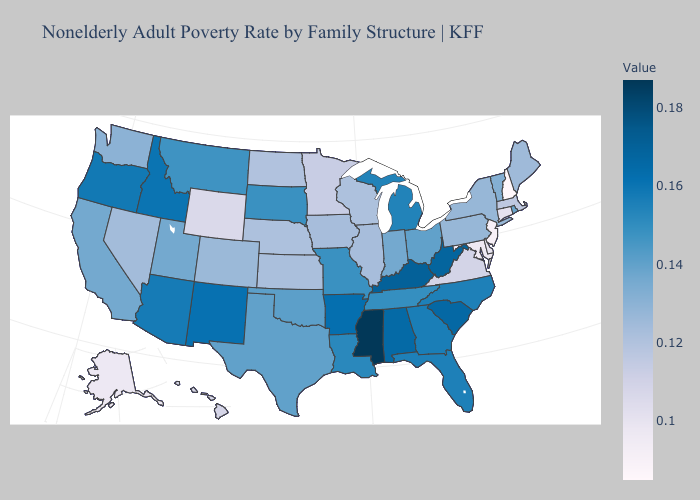Among the states that border Arkansas , which have the highest value?
Keep it brief. Mississippi. Among the states that border Virginia , which have the lowest value?
Short answer required. Maryland. Among the states that border Washington , which have the lowest value?
Give a very brief answer. Oregon. Which states hav the highest value in the Northeast?
Answer briefly. Rhode Island. Among the states that border West Virginia , which have the highest value?
Quick response, please. Kentucky. 